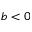<formula> <loc_0><loc_0><loc_500><loc_500>b < 0</formula> 